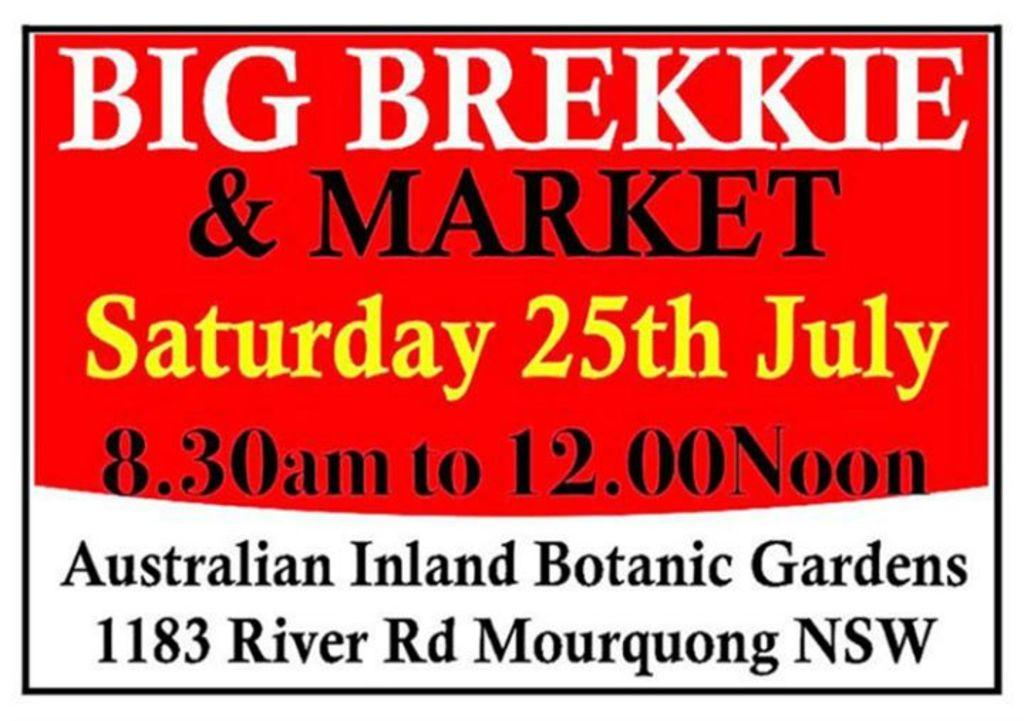What is the main object in the image? There is a pamphlet in the image. What colors are used for the pamphlet? The pamphlet is red and white in color. What can be found on the surface of the pamphlet? There is writing on the pamphlet. What type of coil is wrapped around the pamphlet in the image? There is no coil present in the image; it only features a red and white pamphlet with writing on it. What is the opinion of the person holding the pamphlet in the image? There is no person holding the pamphlet in the image, so it is impossible to determine their opinion. 